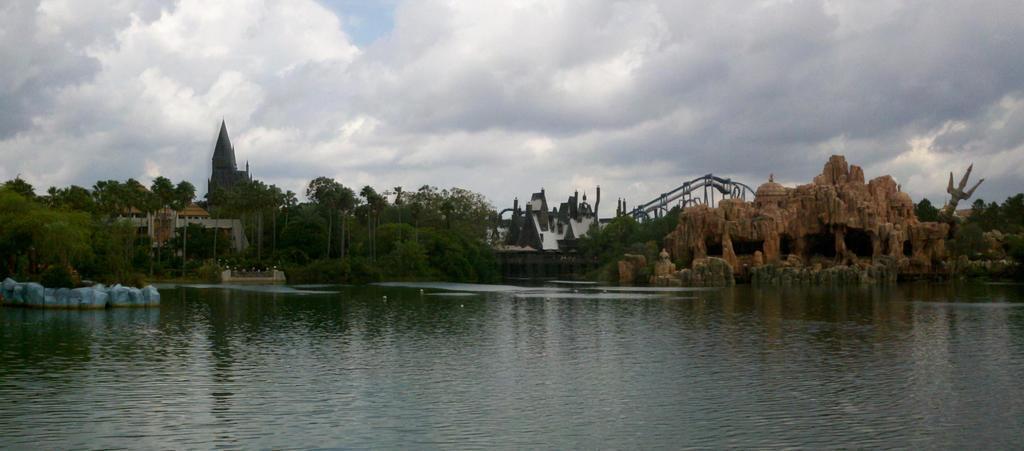Could you give a brief overview of what you see in this image? In this image we can see sky with clouds, trees, castles, rocks and water. 